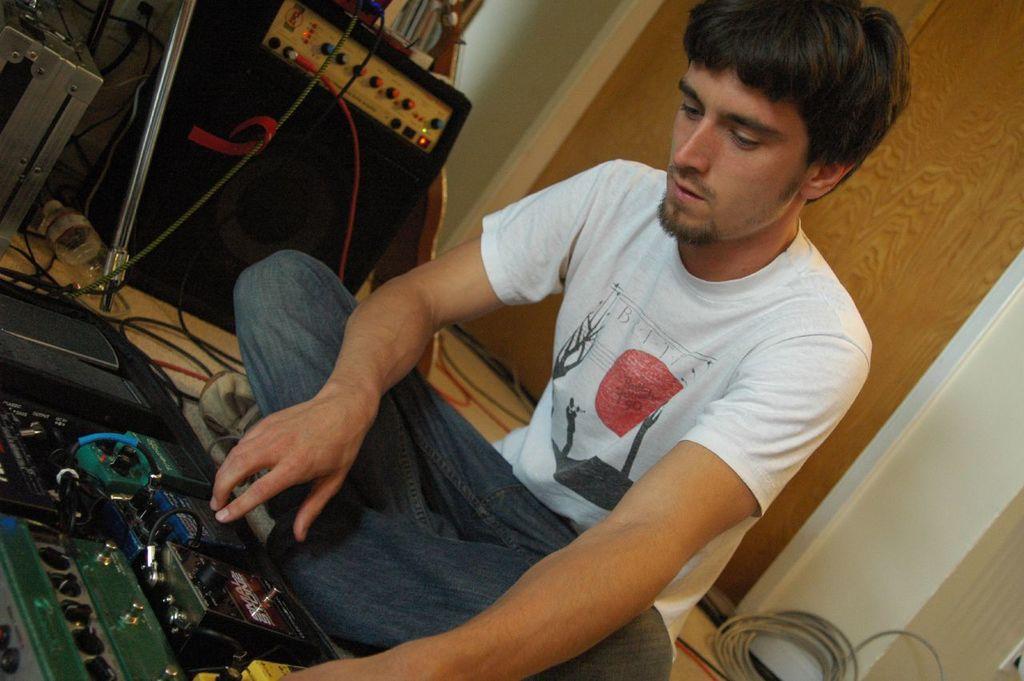Describe this image in one or two sentences. In this image we can see a man is siting on the floor. He is wearing white t-shirt with jeans. In front of him one machine is present and he is doing something with it. Background wall is present and one sound box is there. 